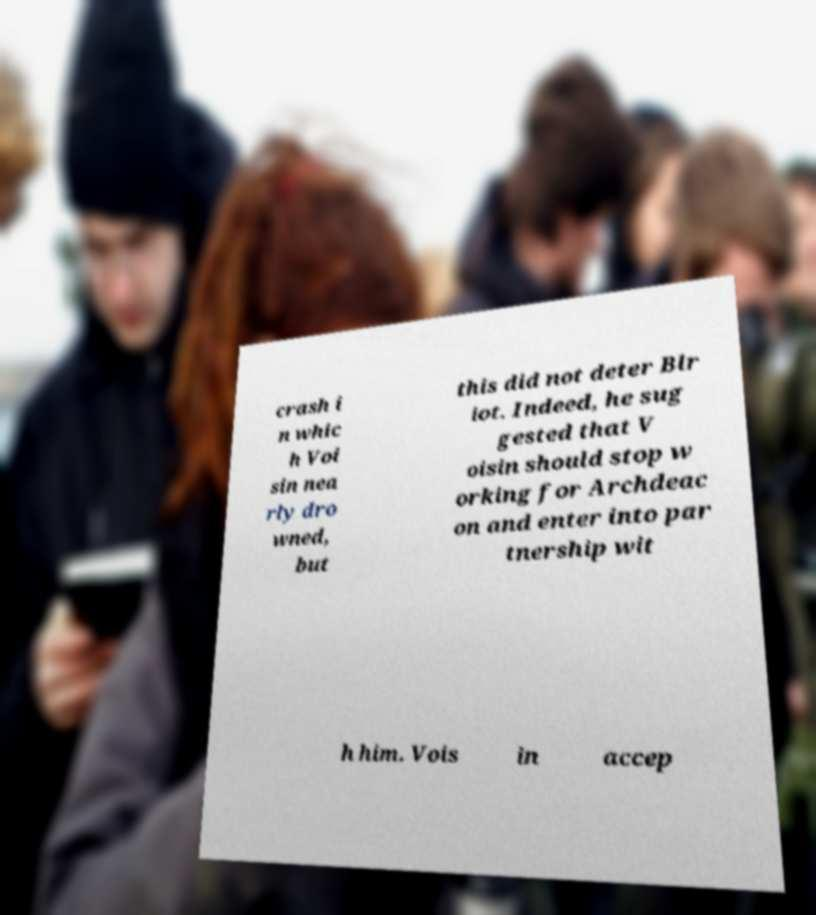Could you extract and type out the text from this image? crash i n whic h Voi sin nea rly dro wned, but this did not deter Blr iot. Indeed, he sug gested that V oisin should stop w orking for Archdeac on and enter into par tnership wit h him. Vois in accep 